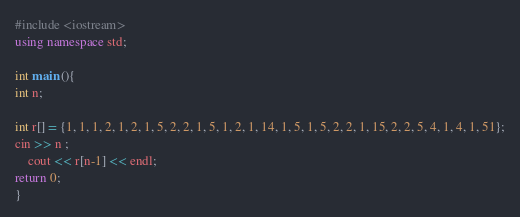Convert code to text. <code><loc_0><loc_0><loc_500><loc_500><_C++_>#include <iostream>
using namespace std;

int main (){
int n;

int r[] = {1, 1, 1, 2, 1, 2, 1, 5, 2, 2, 1, 5, 1, 2, 1, 14, 1, 5, 1, 5, 2, 2, 1, 15, 2, 2, 5, 4, 1, 4, 1, 51};
cin >> n ; 
    cout << r[n-1] << endl;
return 0;
}</code> 